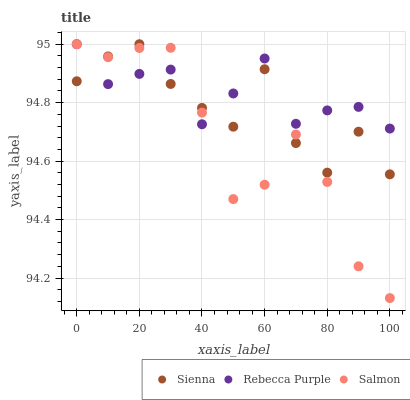Does Salmon have the minimum area under the curve?
Answer yes or no. Yes. Does Rebecca Purple have the maximum area under the curve?
Answer yes or no. Yes. Does Rebecca Purple have the minimum area under the curve?
Answer yes or no. No. Does Salmon have the maximum area under the curve?
Answer yes or no. No. Is Rebecca Purple the smoothest?
Answer yes or no. Yes. Is Sienna the roughest?
Answer yes or no. Yes. Is Salmon the smoothest?
Answer yes or no. No. Is Salmon the roughest?
Answer yes or no. No. Does Salmon have the lowest value?
Answer yes or no. Yes. Does Rebecca Purple have the lowest value?
Answer yes or no. No. Does Rebecca Purple have the highest value?
Answer yes or no. Yes. Does Salmon intersect Sienna?
Answer yes or no. Yes. Is Salmon less than Sienna?
Answer yes or no. No. Is Salmon greater than Sienna?
Answer yes or no. No. 